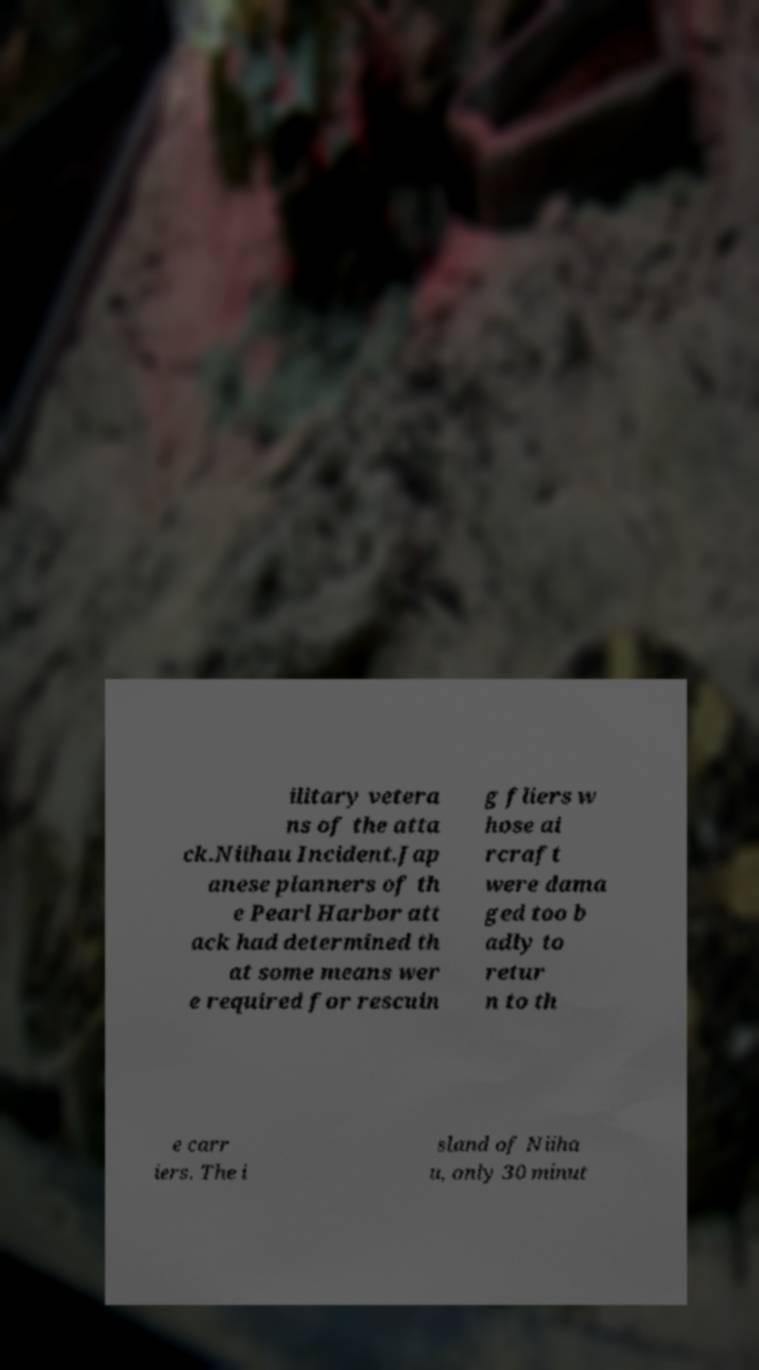Could you assist in decoding the text presented in this image and type it out clearly? ilitary vetera ns of the atta ck.Niihau Incident.Jap anese planners of th e Pearl Harbor att ack had determined th at some means wer e required for rescuin g fliers w hose ai rcraft were dama ged too b adly to retur n to th e carr iers. The i sland of Niiha u, only 30 minut 